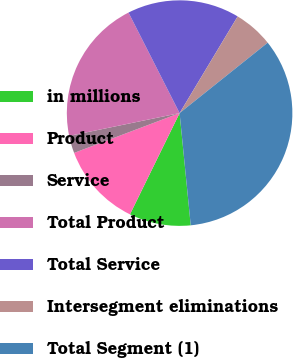Convert chart. <chart><loc_0><loc_0><loc_500><loc_500><pie_chart><fcel>in millions<fcel>Product<fcel>Service<fcel>Total Product<fcel>Total Service<fcel>Intersegment eliminations<fcel>Total Segment (1)<nl><fcel>8.83%<fcel>12.0%<fcel>2.5%<fcel>20.76%<fcel>16.09%<fcel>5.66%<fcel>34.16%<nl></chart> 